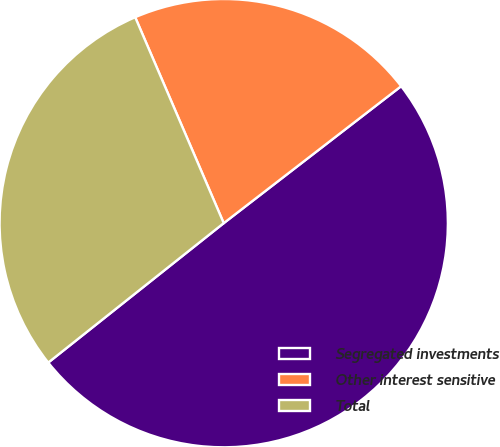<chart> <loc_0><loc_0><loc_500><loc_500><pie_chart><fcel>Segregated investments<fcel>Other interest sensitive<fcel>Total<nl><fcel>49.77%<fcel>21.0%<fcel>29.22%<nl></chart> 